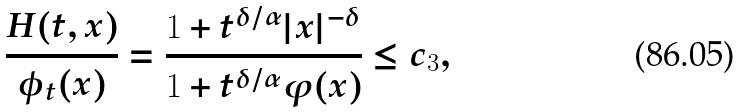<formula> <loc_0><loc_0><loc_500><loc_500>\frac { H ( t , x ) } { \phi _ { t } ( x ) } = \frac { 1 + t ^ { \delta / \alpha } | x | ^ { - \delta } } { 1 + t ^ { \delta / \alpha } \varphi ( x ) } \leq c _ { 3 } ,</formula> 